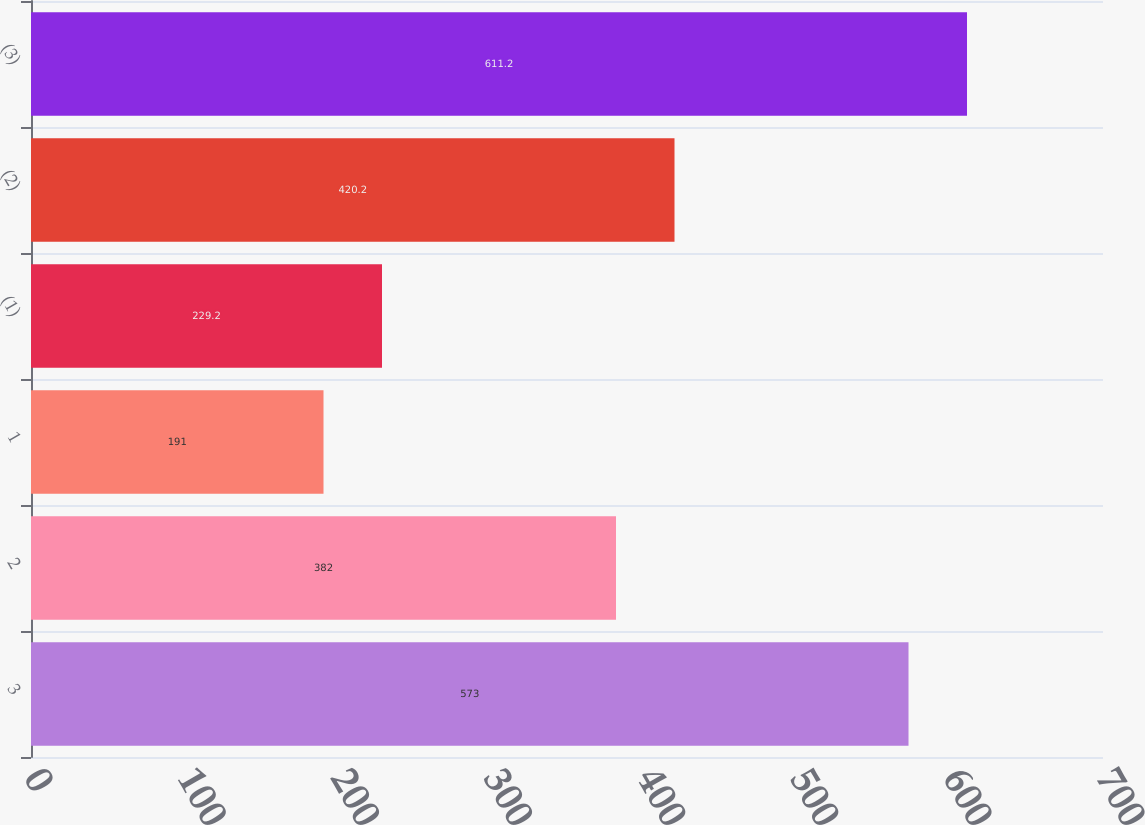Convert chart. <chart><loc_0><loc_0><loc_500><loc_500><bar_chart><fcel>3<fcel>2<fcel>1<fcel>(1)<fcel>(2)<fcel>(3)<nl><fcel>573<fcel>382<fcel>191<fcel>229.2<fcel>420.2<fcel>611.2<nl></chart> 